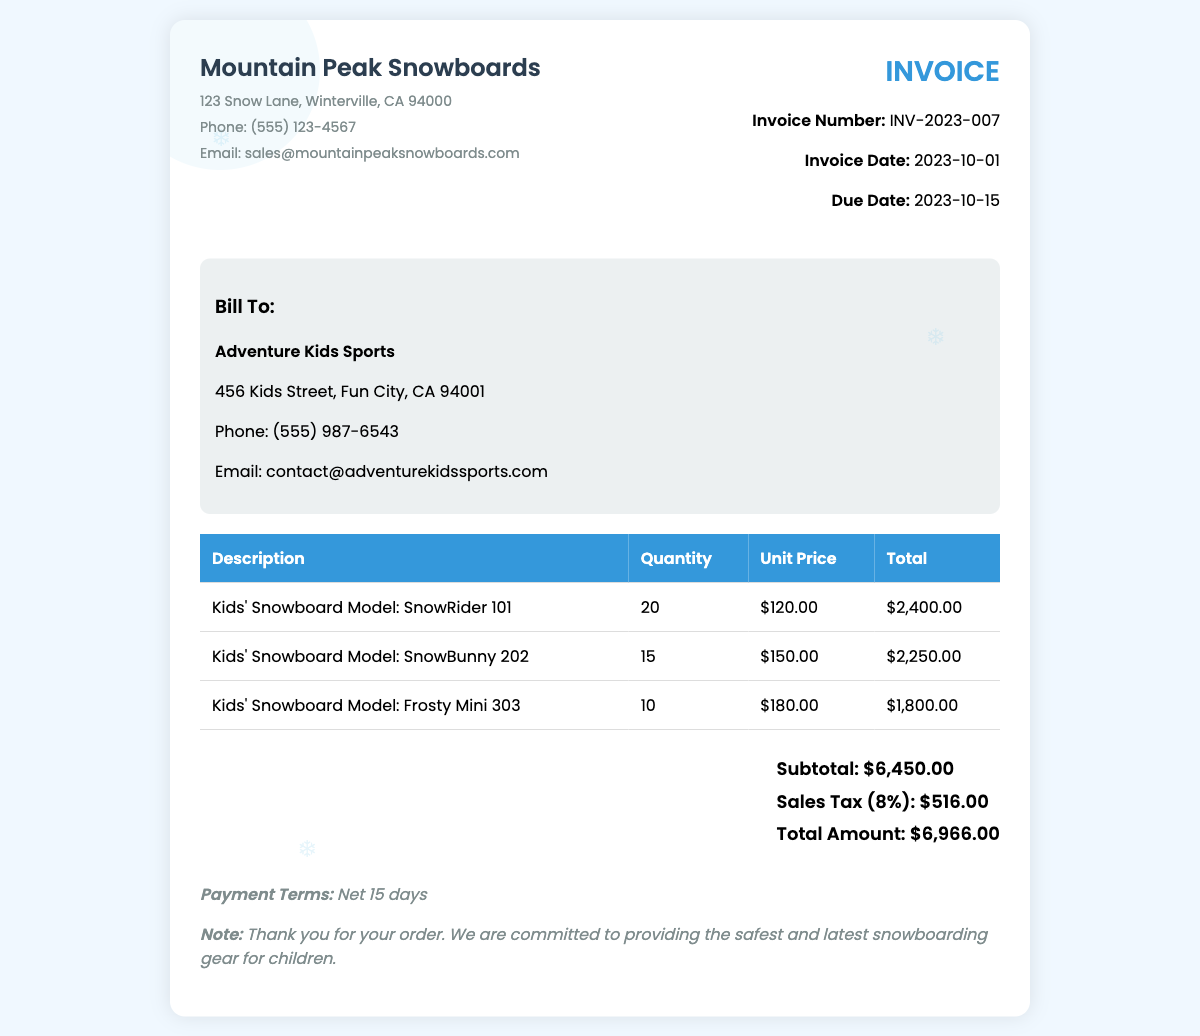what is the invoice number? The invoice number is listed in the invoice details section.
Answer: INV-2023-007 what is the due date for the invoice? The due date is specified beneath the invoice date.
Answer: 2023-10-15 how many units of SnowBunny 202 were sold? The quantity sold is shown in the table under the Quantity column for SnowBunny 202.
Answer: 15 what is the sales tax percentage applied? The sales tax percentage is indicated in the total section as 8%.
Answer: 8% what is the total amount due? The total amount due is displayed prominently in the total section of the invoice.
Answer: $6,966.00 how much is the unit price of Frosty Mini 303? The unit price can be found in the table under the Unit Price column for Frosty Mini 303.
Answer: $180.00 who is the bill to in this invoice? The bill-to information is located in the customer info section at the top.
Answer: Adventure Kids Sports what is the payment terms for this invoice? The payment terms are stated in the notes section at the bottom of the invoice.
Answer: Net 15 days what is the subtotal amount before tax? The subtotal is listed in the total section as the amount before sales tax is added.
Answer: $6,450.00 